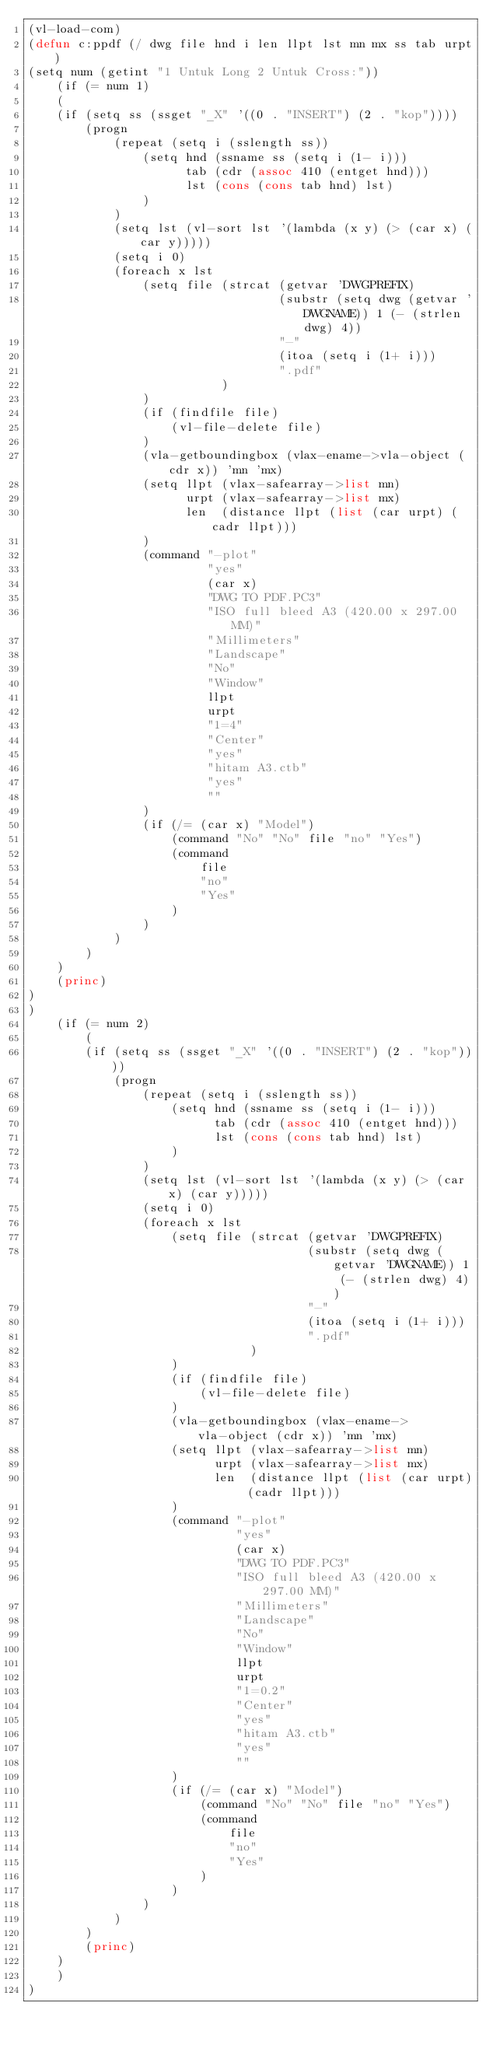<code> <loc_0><loc_0><loc_500><loc_500><_Lisp_>(vl-load-com)
(defun c:ppdf (/ dwg file hnd i len llpt lst mn mx ss tab urpt)
(setq num (getint "1 Untuk Long 2 Untuk Cross:"))
	(if (= num 1)
	(
    (if (setq ss (ssget "_X" '((0 . "INSERT") (2 . "kop"))))
        (progn
            (repeat (setq i (sslength ss))
                (setq hnd (ssname ss (setq i (1- i)))
                      tab (cdr (assoc 410 (entget hnd)))
                      lst (cons (cons tab hnd) lst)
                )
            )
            (setq lst (vl-sort lst '(lambda (x y) (> (car x) (car y)))))
            (setq i 0)
            (foreach x lst
                (setq file (strcat (getvar 'DWGPREFIX)
                                   (substr (setq dwg (getvar 'DWGNAME)) 1 (- (strlen dwg) 4))
                                   "-"
                                   (itoa (setq i (1+ i)))
                                   ".pdf"
                           )
                )
                (if (findfile file)
                    (vl-file-delete file)
                )
                (vla-getboundingbox (vlax-ename->vla-object (cdr x)) 'mn 'mx)
                (setq llpt (vlax-safearray->list mn)
                      urpt (vlax-safearray->list mx)
                      len  (distance llpt (list (car urpt) (cadr llpt)))
                )
                (command "-plot"
                         "yes"
                         (car x)
                         "DWG TO PDF.PC3"
                         "ISO full bleed A3 (420.00 x 297.00 MM)"
                         "Millimeters"
                         "Landscape"
                         "No"
                         "Window"
                         llpt
                         urpt
                         "1=4"
                         "Center"
                         "yes"
                         "hitam A3.ctb"
                         "yes"
                         ""
                )
                (if (/= (car x) "Model")
                    (command "No" "No" file "no" "Yes")
                    (command
                        file
                        "no"
                        "Yes"
                    )
                )
            )
        )
    )
    (princ)
)
)
	(if (= num 2)
		(
		(if (setq ss (ssget "_X" '((0 . "INSERT") (2 . "kop"))))
			(progn
				(repeat (setq i (sslength ss))
					(setq hnd (ssname ss (setq i (1- i)))
						  tab (cdr (assoc 410 (entget hnd)))
						  lst (cons (cons tab hnd) lst)
					)
				)
				(setq lst (vl-sort lst '(lambda (x y) (> (car x) (car y)))))
				(setq i 0)
				(foreach x lst
					(setq file (strcat (getvar 'DWGPREFIX)
									   (substr (setq dwg (getvar 'DWGNAME)) 1 (- (strlen dwg) 4))
									   "-"
									   (itoa (setq i (1+ i)))
									   ".pdf"
							   )
					)
					(if (findfile file)
						(vl-file-delete file)
					)
					(vla-getboundingbox (vlax-ename->vla-object (cdr x)) 'mn 'mx)
					(setq llpt (vlax-safearray->list mn)
						  urpt (vlax-safearray->list mx)
						  len  (distance llpt (list (car urpt) (cadr llpt)))
					)
					(command "-plot"
							 "yes"
							 (car x)
							 "DWG TO PDF.PC3"
							 "ISO full bleed A3 (420.00 x 297.00 MM)"
							 "Millimeters"
							 "Landscape"
							 "No"
							 "Window"
							 llpt
							 urpt
							 "1=0.2"
							 "Center"
							 "yes"
							 "hitam A3.ctb"
							 "yes"
							 ""
					)
					(if (/= (car x) "Model")
						(command "No" "No" file "no" "Yes")
						(command
							file
							"no"
							"Yes"
						)
					)
				)
			)
		)
		(princ)
	)
	)
)</code> 